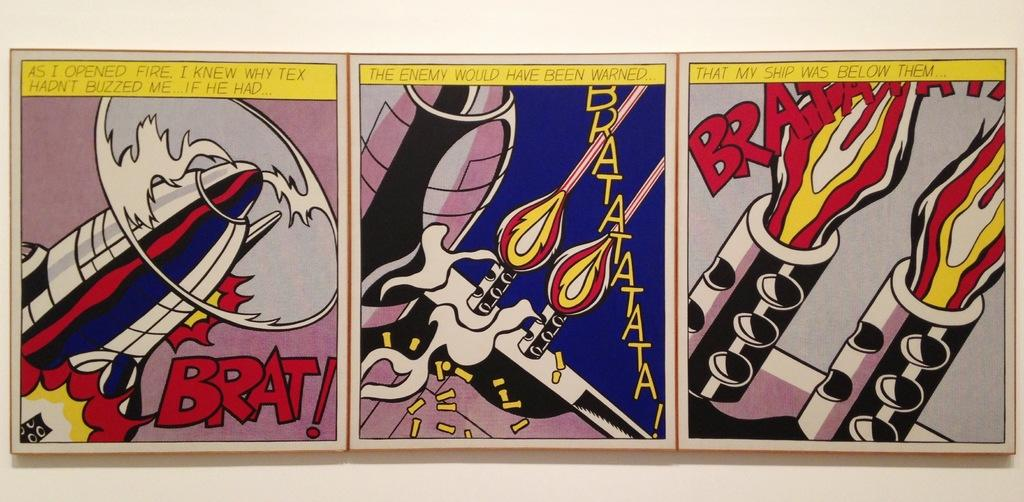What type of images are present in the image? There are pictures of cartoons in the image. What additional feature can be observed on the pictures of cartoons? There is text on the pictures of cartoons. Can you touch the wrench that is being used by the cartoon character in the image? There is no wrench present in the image, and it is not possible to touch any objects within a two-dimensional image. 